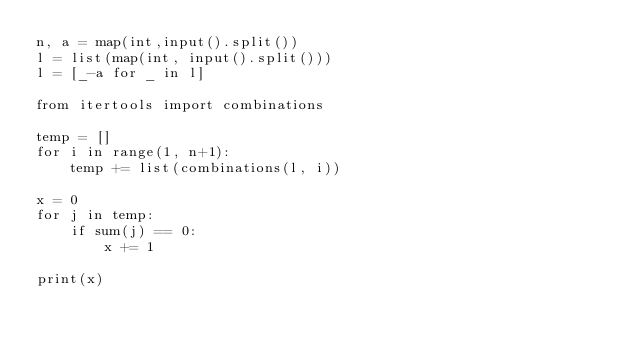<code> <loc_0><loc_0><loc_500><loc_500><_Python_>n, a = map(int,input().split())
l = list(map(int, input().split()))
l = [_-a for _ in l]

from itertools import combinations

temp = []
for i in range(1, n+1):
    temp += list(combinations(l, i))

x = 0
for j in temp:
    if sum(j) == 0:
        x += 1

print(x)</code> 